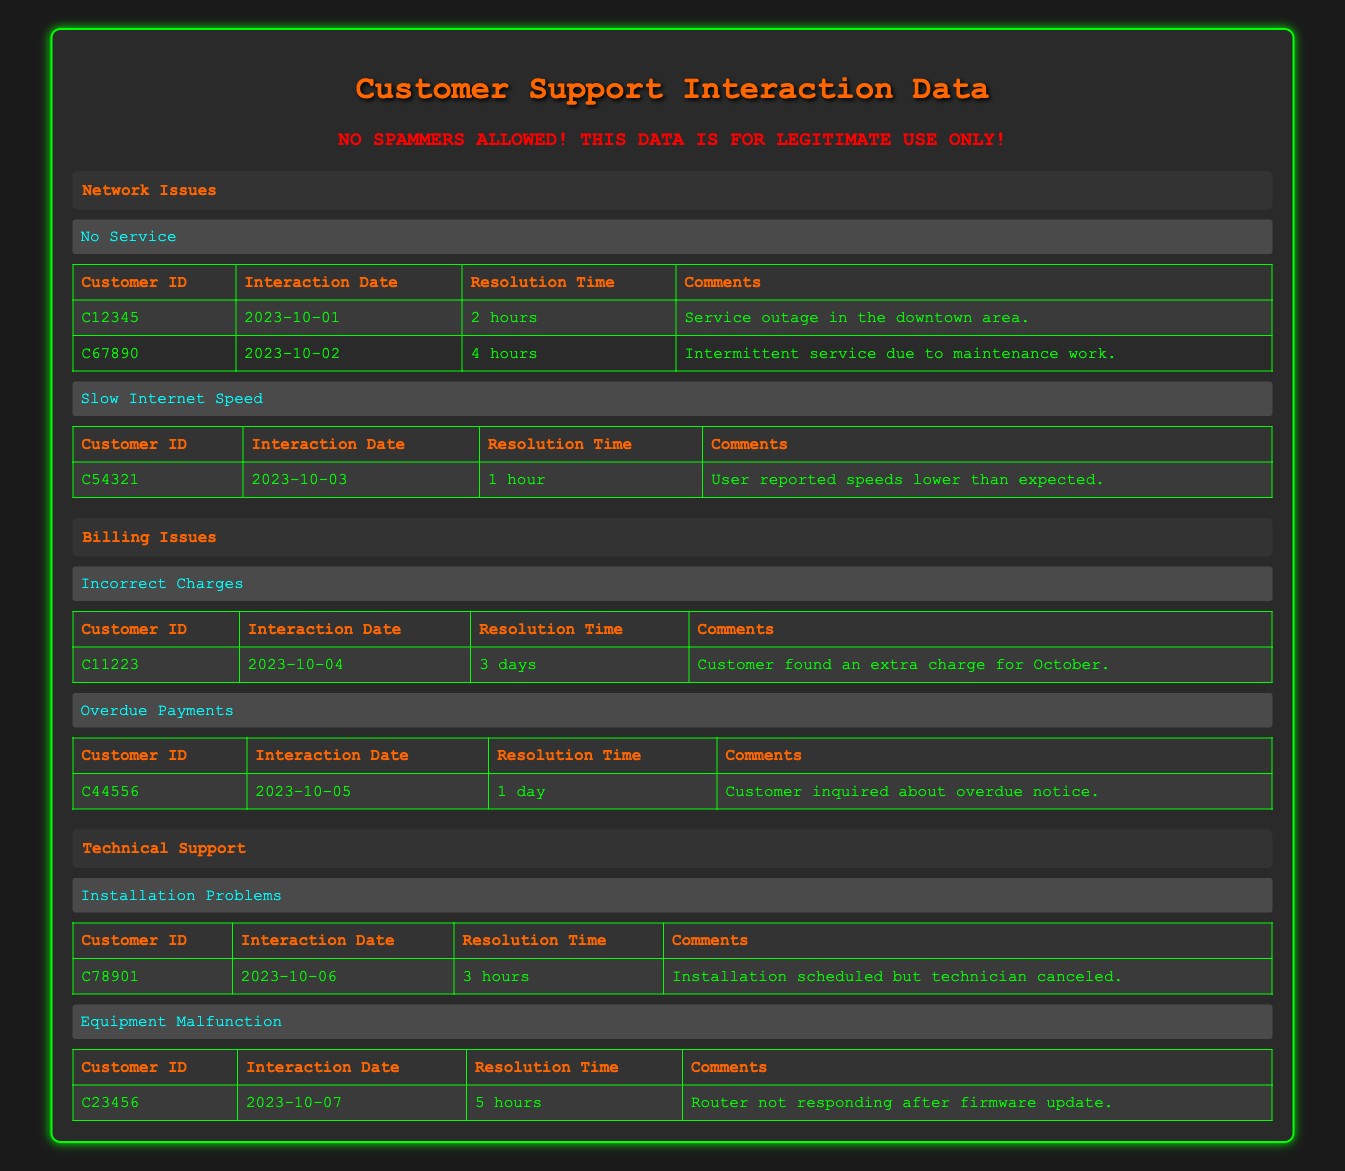What is the resolution time for the issue of "No Service"? For "No Service," there are two interactions: the first has a resolution time of 2 hours, and the second has a resolution time of 4 hours. Thus, the resolution times involved here are 2 hours and 4 hours.
Answer: 2 hours for one case and 4 hours for another How many customers reported "Equipment Malfunction"? There is only one interaction listed under the "Equipment Malfunction" sub-issue, which is for Customer ID C23456.
Answer: One customer reported it What is the average resolution time for all issues listed? We need to add all the resolution times for each interaction: 2 hours (No Service) + 4 hours (No Service) + 1 hour (Slow Internet) + 3 days (Incorrect Charges) + 1 day (Overdue Payments) + 3 hours (Installation Problems) + 5 hours (Equipment Malfunction). Convert days to hours (3 days = 72 hours and 1 day = 24 hours), totaling: 2 + 4 + 1 + 72 + 24 + 3 + 5 = 111 hours. There are 7 interactions, so the average is 111 hours / 7 ≈ 15.86 hours.
Answer: Approximately 15.86 hours Did any customer interaction regarding "Slow Internet Speed" take longer than 2 hours to resolve? There is only one interaction recorded under "Slow Internet Speed," which has a resolution time of 1 hour. Therefore, there are no interactions longer than 2 hours for that issue.
Answer: No Which customer had the longest resolution time and what was the issue? Reviewing all interactions, the longest resolution time is 3 days for the "Incorrect Charges" issue with Customer ID C11223. Although there are also longer times in hours, when converted, the maximum is from the single "Incorrect Charges" interaction.
Answer: Customer C11223 with "Incorrect Charges" has the longest resolution time of 3 days 